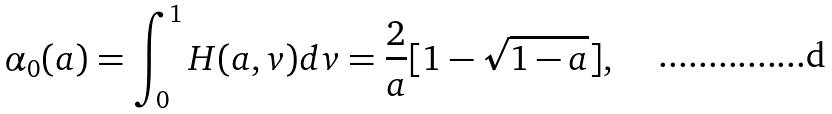<formula> <loc_0><loc_0><loc_500><loc_500>\alpha _ { 0 } ( a ) = \int _ { 0 } ^ { 1 } H ( a , v ) d v = \frac { 2 } { a } [ 1 - \sqrt { 1 - a } ] ,</formula> 